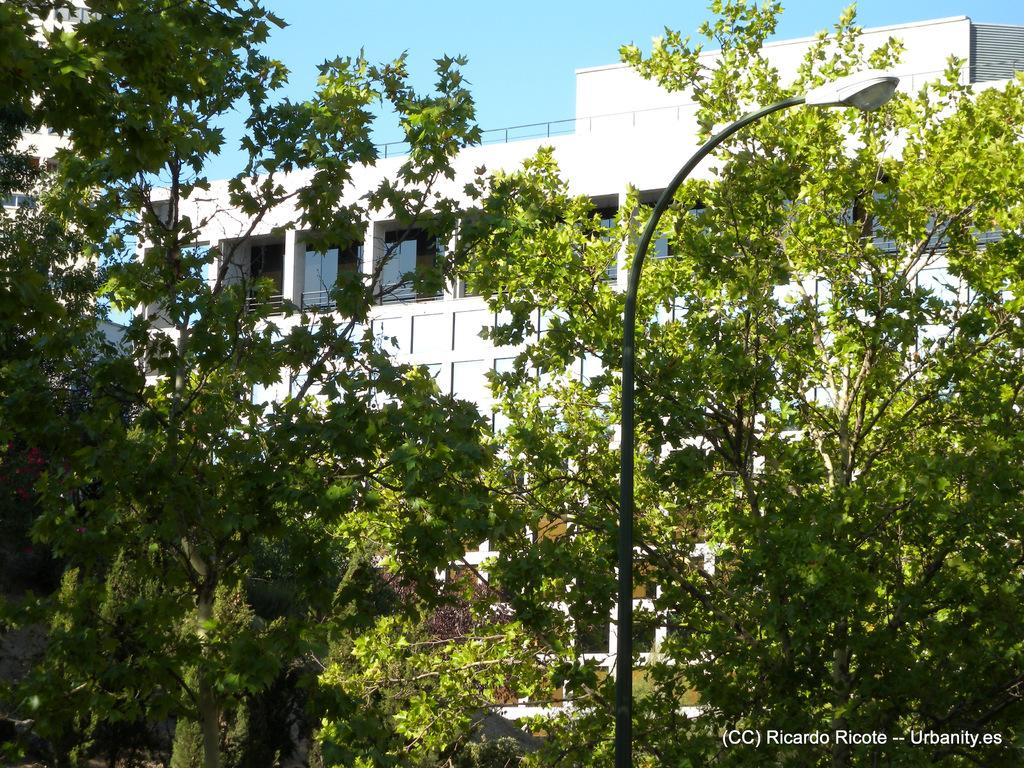What type of structure is present in the image? There is a building in the image. What else can be seen in the image besides the building? There are many plants and trees in the image. Can you describe the lighting in the image? There is a street light in the image. How many stars can be seen in the image? There are no stars visible in the image. 